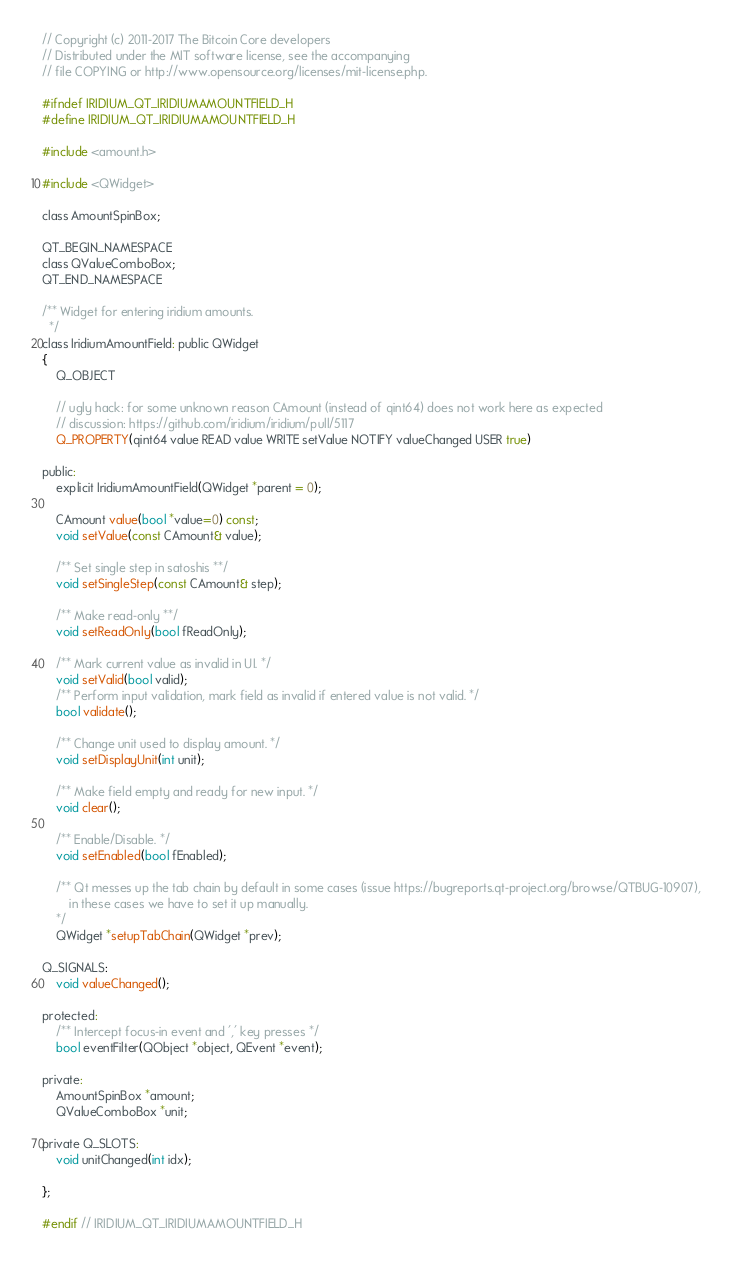<code> <loc_0><loc_0><loc_500><loc_500><_C_>// Copyright (c) 2011-2017 The Bitcoin Core developers
// Distributed under the MIT software license, see the accompanying
// file COPYING or http://www.opensource.org/licenses/mit-license.php.

#ifndef IRIDIUM_QT_IRIDIUMAMOUNTFIELD_H
#define IRIDIUM_QT_IRIDIUMAMOUNTFIELD_H

#include <amount.h>

#include <QWidget>

class AmountSpinBox;

QT_BEGIN_NAMESPACE
class QValueComboBox;
QT_END_NAMESPACE

/** Widget for entering iridium amounts.
  */
class IridiumAmountField: public QWidget
{
    Q_OBJECT

    // ugly hack: for some unknown reason CAmount (instead of qint64) does not work here as expected
    // discussion: https://github.com/iridium/iridium/pull/5117
    Q_PROPERTY(qint64 value READ value WRITE setValue NOTIFY valueChanged USER true)

public:
    explicit IridiumAmountField(QWidget *parent = 0);

    CAmount value(bool *value=0) const;
    void setValue(const CAmount& value);

    /** Set single step in satoshis **/
    void setSingleStep(const CAmount& step);

    /** Make read-only **/
    void setReadOnly(bool fReadOnly);

    /** Mark current value as invalid in UI. */
    void setValid(bool valid);
    /** Perform input validation, mark field as invalid if entered value is not valid. */
    bool validate();

    /** Change unit used to display amount. */
    void setDisplayUnit(int unit);

    /** Make field empty and ready for new input. */
    void clear();

    /** Enable/Disable. */
    void setEnabled(bool fEnabled);

    /** Qt messes up the tab chain by default in some cases (issue https://bugreports.qt-project.org/browse/QTBUG-10907),
        in these cases we have to set it up manually.
    */
    QWidget *setupTabChain(QWidget *prev);

Q_SIGNALS:
    void valueChanged();

protected:
    /** Intercept focus-in event and ',' key presses */
    bool eventFilter(QObject *object, QEvent *event);

private:
    AmountSpinBox *amount;
    QValueComboBox *unit;

private Q_SLOTS:
    void unitChanged(int idx);

};

#endif // IRIDIUM_QT_IRIDIUMAMOUNTFIELD_H
</code> 